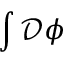Convert formula to latex. <formula><loc_0><loc_0><loc_500><loc_500>\int { \mathcal { D } } \phi</formula> 